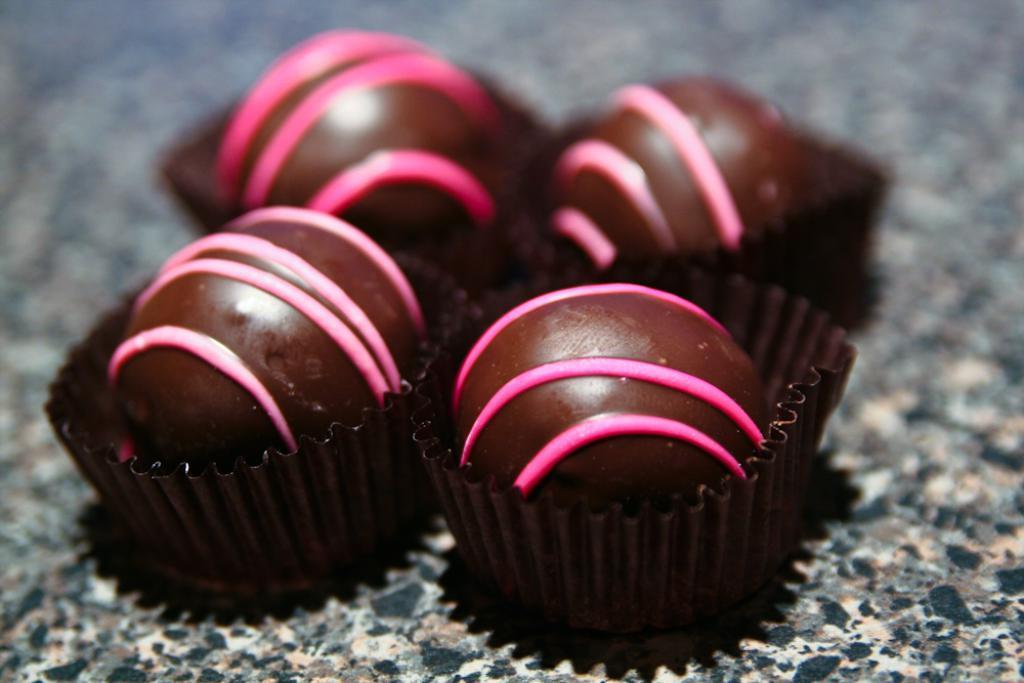Could you give a brief overview of what you see in this image? This image consists of food. 